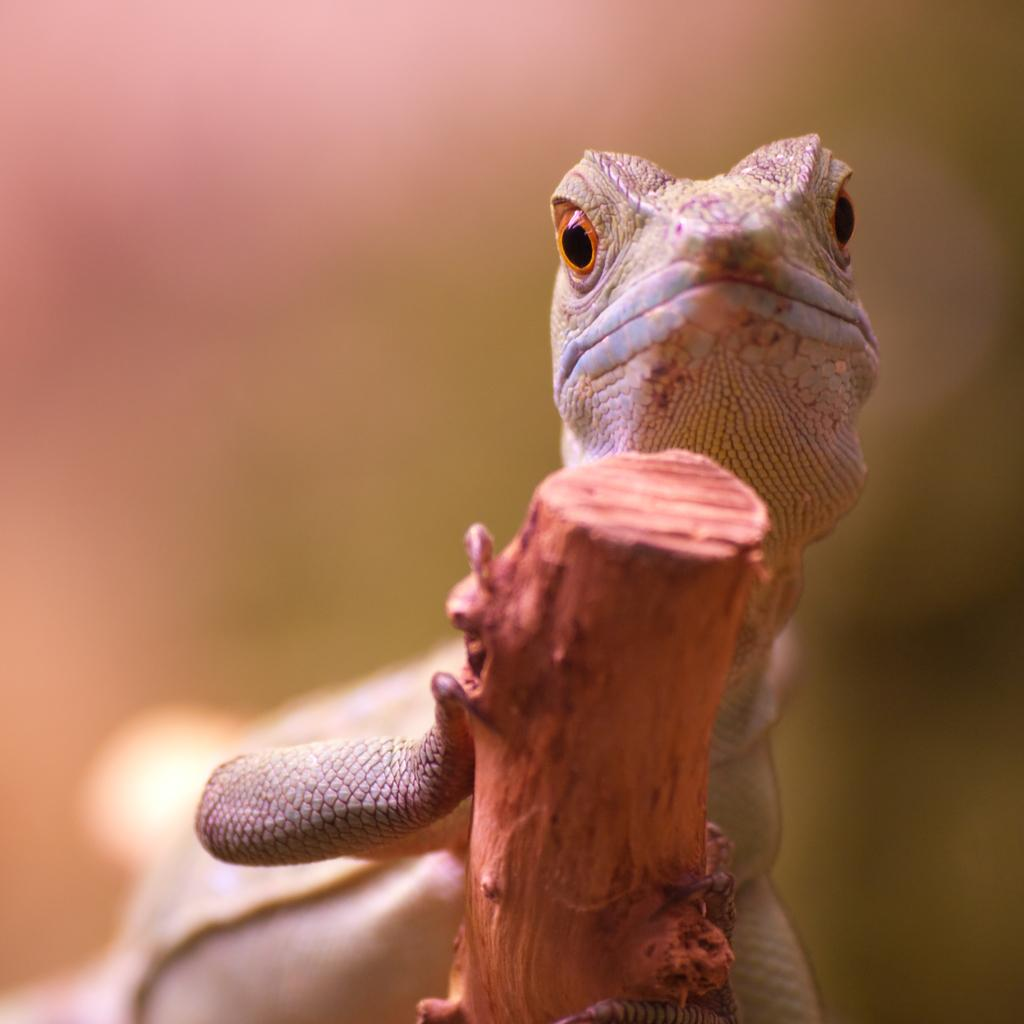What type of animal is in the image? There is a lizard in the image. What is the lizard positioned on? The lizard is on a wooden stick. Can you describe the background of the image? The background of the image is blurred. How many passengers are visible on the lizard's leg in the image? There are no passengers or legs visible in the image, as it features a lizard on a wooden stick with a blurred background. 